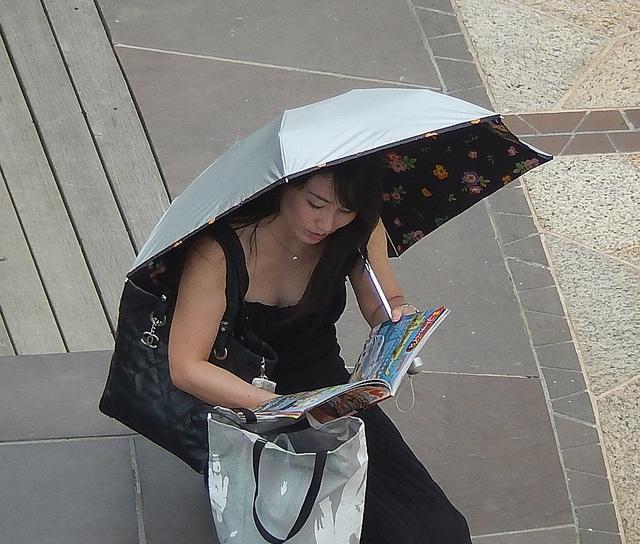What does the lady use the umbrella for?
Answer the question by selecting the correct answer among the 4 following choices and explain your choice with a short sentence. The answer should be formatted with the following format: `Answer: choice
Rationale: rationale.`
Options: Hail, rain, wind, shade. Answer: shade.
Rationale: The lady is sitting outside and needs some protection from the sun and glare in order to read her magazine. 